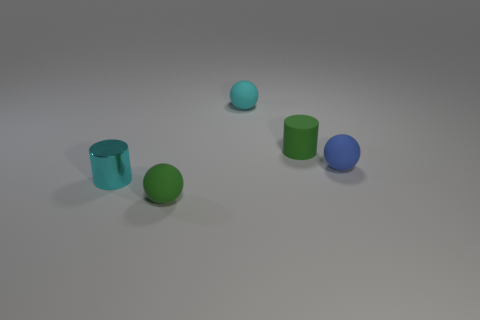There is a tiny cyan object in front of the rubber thing on the right side of the rubber cylinder; what is its material?
Your response must be concise. Metal. What is the material of the cyan ball that is the same size as the green cylinder?
Provide a short and direct response. Rubber. There is a matte object that is in front of the metallic cylinder; does it have the same size as the blue rubber thing?
Provide a succinct answer. Yes. There is a small rubber thing that is in front of the shiny thing; is it the same shape as the small cyan metallic thing?
Make the answer very short. No. How many things are tiny blue objects or small things that are in front of the small matte cylinder?
Ensure brevity in your answer.  3. Are there fewer tiny purple rubber spheres than small green rubber spheres?
Offer a very short reply. Yes. Is the number of matte cylinders greater than the number of brown cylinders?
Keep it short and to the point. Yes. What number of other objects are the same material as the tiny green cylinder?
Keep it short and to the point. 3. How many small cylinders are left of the small object to the left of the small rubber ball that is in front of the blue thing?
Your response must be concise. 0. What number of matte things are either gray cylinders or balls?
Your answer should be very brief. 3. 